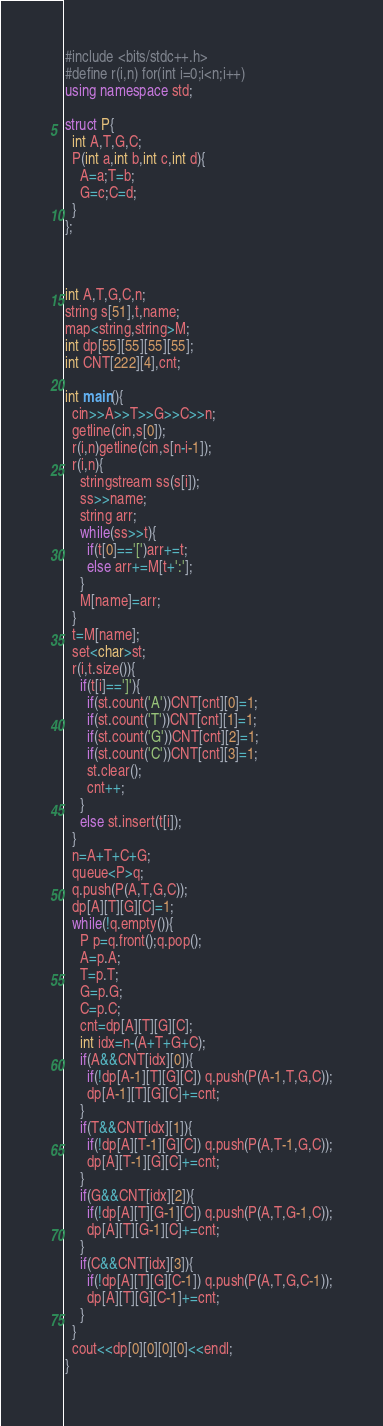<code> <loc_0><loc_0><loc_500><loc_500><_C++_>#include <bits/stdc++.h>
#define r(i,n) for(int i=0;i<n;i++)
using namespace std;

struct P{
  int A,T,G,C;
  P(int a,int b,int c,int d){
    A=a;T=b;
    G=c;C=d;
  }
};



int A,T,G,C,n;
string s[51],t,name;
map<string,string>M;
int dp[55][55][55][55];
int CNT[222][4],cnt;

int main(){
  cin>>A>>T>>G>>C>>n;
  getline(cin,s[0]);
  r(i,n)getline(cin,s[n-i-1]);
  r(i,n){
    stringstream ss(s[i]);
    ss>>name;
    string arr;
    while(ss>>t){
      if(t[0]=='[')arr+=t;
      else arr+=M[t+':'];
    }
    M[name]=arr;
  }
  t=M[name];
  set<char>st;
  r(i,t.size()){
    if(t[i]==']'){
      if(st.count('A'))CNT[cnt][0]=1;
      if(st.count('T'))CNT[cnt][1]=1;
      if(st.count('G'))CNT[cnt][2]=1;
      if(st.count('C'))CNT[cnt][3]=1;
      st.clear();
      cnt++;
    }
    else st.insert(t[i]);
  }
  n=A+T+C+G;
  queue<P>q;
  q.push(P(A,T,G,C));
  dp[A][T][G][C]=1;
  while(!q.empty()){
    P p=q.front();q.pop();
    A=p.A;
    T=p.T;
    G=p.G;
    C=p.C;
    cnt=dp[A][T][G][C];
    int idx=n-(A+T+G+C);
    if(A&&CNT[idx][0]){
      if(!dp[A-1][T][G][C]) q.push(P(A-1,T,G,C));
      dp[A-1][T][G][C]+=cnt;
    }
    if(T&&CNT[idx][1]){
      if(!dp[A][T-1][G][C]) q.push(P(A,T-1,G,C));
      dp[A][T-1][G][C]+=cnt;
    }
    if(G&&CNT[idx][2]){
      if(!dp[A][T][G-1][C]) q.push(P(A,T,G-1,C));
      dp[A][T][G-1][C]+=cnt;
    }
    if(C&&CNT[idx][3]){
      if(!dp[A][T][G][C-1]) q.push(P(A,T,G,C-1));
      dp[A][T][G][C-1]+=cnt;
    }
  }
  cout<<dp[0][0][0][0]<<endl;
}
</code> 